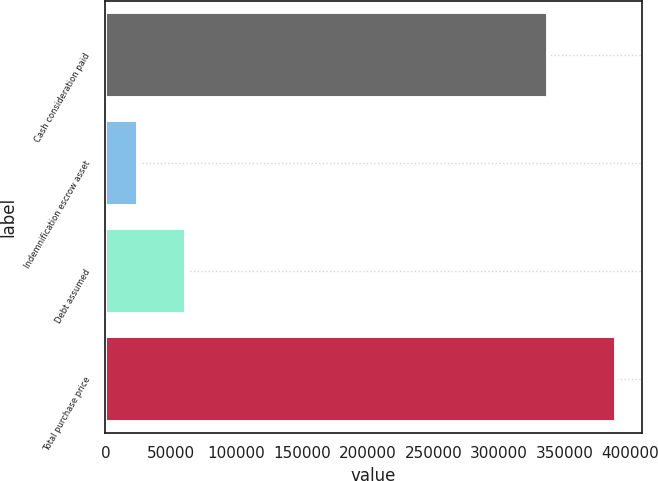Convert chart to OTSL. <chart><loc_0><loc_0><loc_500><loc_500><bar_chart><fcel>Cash consideration paid<fcel>Indemnification escrow asset<fcel>Debt assumed<fcel>Total purchase price<nl><fcel>337123<fcel>25140<fcel>61546.5<fcel>389205<nl></chart> 